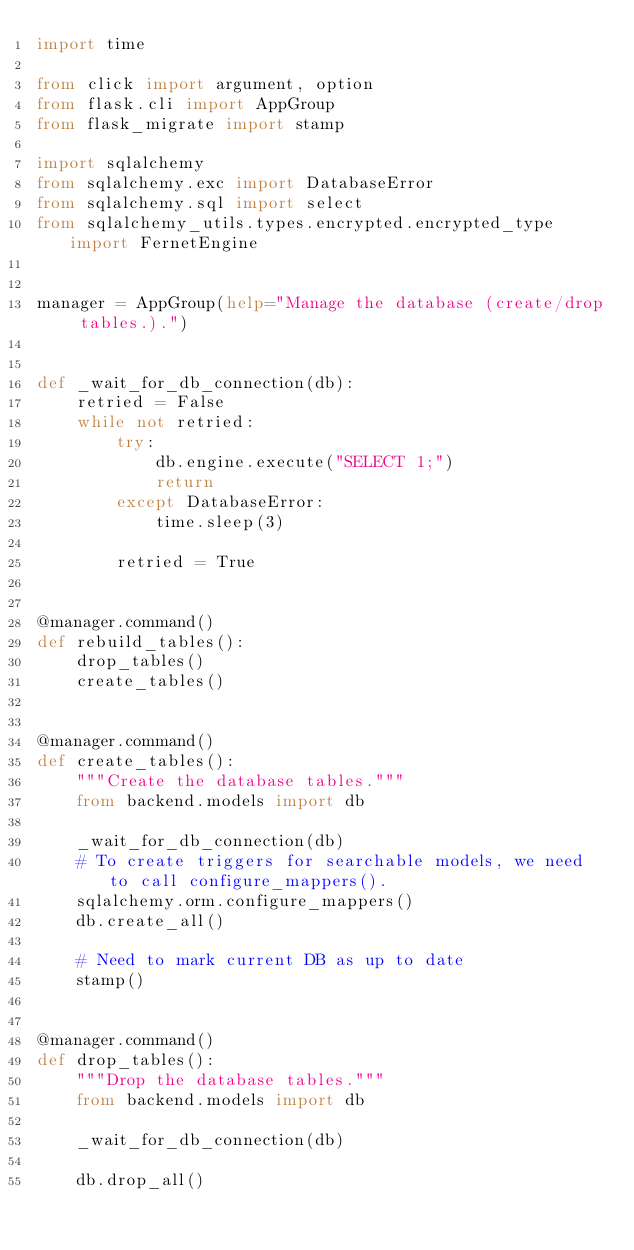Convert code to text. <code><loc_0><loc_0><loc_500><loc_500><_Python_>import time

from click import argument, option
from flask.cli import AppGroup
from flask_migrate import stamp

import sqlalchemy
from sqlalchemy.exc import DatabaseError
from sqlalchemy.sql import select
from sqlalchemy_utils.types.encrypted.encrypted_type import FernetEngine


manager = AppGroup(help="Manage the database (create/drop tables.).")


def _wait_for_db_connection(db):
    retried = False
    while not retried:
        try:
            db.engine.execute("SELECT 1;")
            return
        except DatabaseError:
            time.sleep(3)

        retried = True


@manager.command()
def rebuild_tables():
    drop_tables()
    create_tables()


@manager.command()
def create_tables():
    """Create the database tables."""
    from backend.models import db

    _wait_for_db_connection(db)
    # To create triggers for searchable models, we need to call configure_mappers().
    sqlalchemy.orm.configure_mappers()
    db.create_all()

    # Need to mark current DB as up to date
    stamp()


@manager.command()
def drop_tables():
    """Drop the database tables."""
    from backend.models import db

    _wait_for_db_connection(db)

    db.drop_all()
</code> 